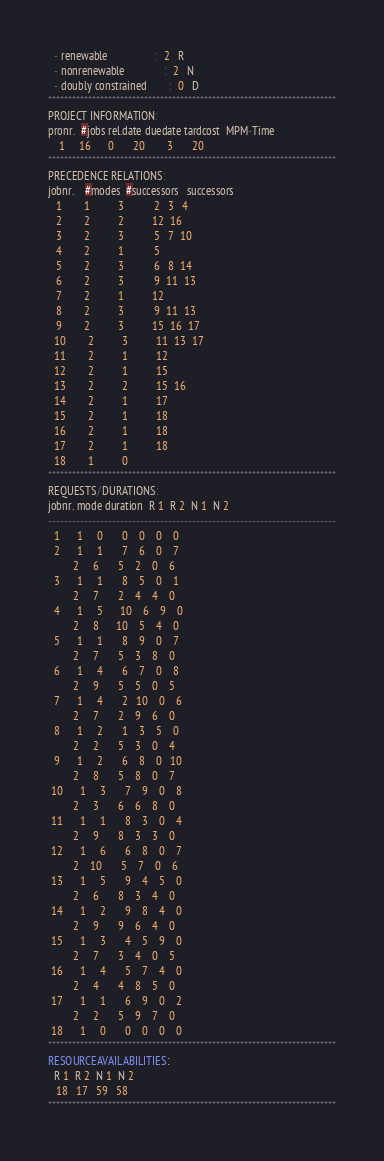Convert code to text. <code><loc_0><loc_0><loc_500><loc_500><_ObjectiveC_>  - renewable                 :  2   R
  - nonrenewable              :  2   N
  - doubly constrained        :  0   D
************************************************************************
PROJECT INFORMATION:
pronr.  #jobs rel.date duedate tardcost  MPM-Time
    1     16      0       20        3       20
************************************************************************
PRECEDENCE RELATIONS:
jobnr.    #modes  #successors   successors
   1        1          3           2   3   4
   2        2          2          12  16
   3        2          3           5   7  10
   4        2          1           5
   5        2          3           6   8  14
   6        2          3           9  11  13
   7        2          1          12
   8        2          3           9  11  13
   9        2          3          15  16  17
  10        2          3          11  13  17
  11        2          1          12
  12        2          1          15
  13        2          2          15  16
  14        2          1          17
  15        2          1          18
  16        2          1          18
  17        2          1          18
  18        1          0        
************************************************************************
REQUESTS/DURATIONS:
jobnr. mode duration  R 1  R 2  N 1  N 2
------------------------------------------------------------------------
  1      1     0       0    0    0    0
  2      1     1       7    6    0    7
         2     6       5    2    0    6
  3      1     1       8    5    0    1
         2     7       2    4    4    0
  4      1     5      10    6    9    0
         2     8      10    5    4    0
  5      1     1       8    9    0    7
         2     7       5    3    8    0
  6      1     4       6    7    0    8
         2     9       5    5    0    5
  7      1     4       2   10    0    6
         2     7       2    9    6    0
  8      1     2       1    3    5    0
         2     2       5    3    0    4
  9      1     2       6    8    0   10
         2     8       5    8    0    7
 10      1     3       7    9    0    8
         2     3       6    6    8    0
 11      1     1       8    3    0    4
         2     9       8    3    3    0
 12      1     6       6    8    0    7
         2    10       5    7    0    6
 13      1     5       9    4    5    0
         2     6       8    3    4    0
 14      1     2       9    8    4    0
         2     9       9    6    4    0
 15      1     3       4    5    9    0
         2     7       3    4    0    5
 16      1     4       5    7    4    0
         2     4       4    8    5    0
 17      1     1       6    9    0    2
         2     2       5    9    7    0
 18      1     0       0    0    0    0
************************************************************************
RESOURCEAVAILABILITIES:
  R 1  R 2  N 1  N 2
   18   17   59   58
************************************************************************
</code> 